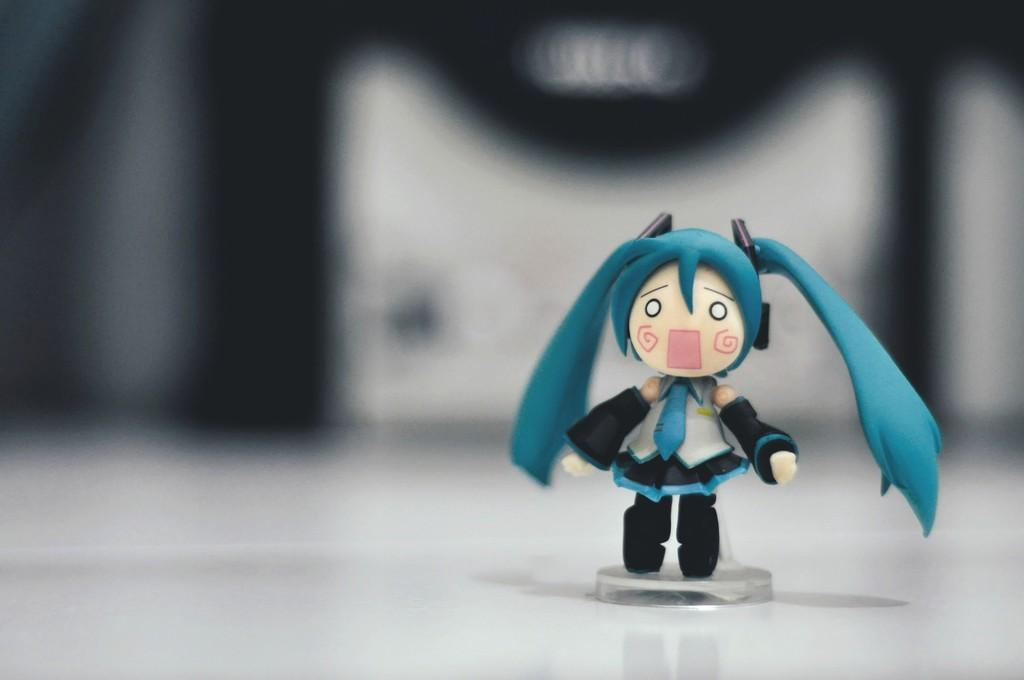What object can be seen in the image? There is a toy in the image. What colors are present on the toy? The toy has white, blue, and white colors. What is the color scheme of the background in the image? The background of the image is black and white. What shape is the note written on in the image? There is no note present in the image. 